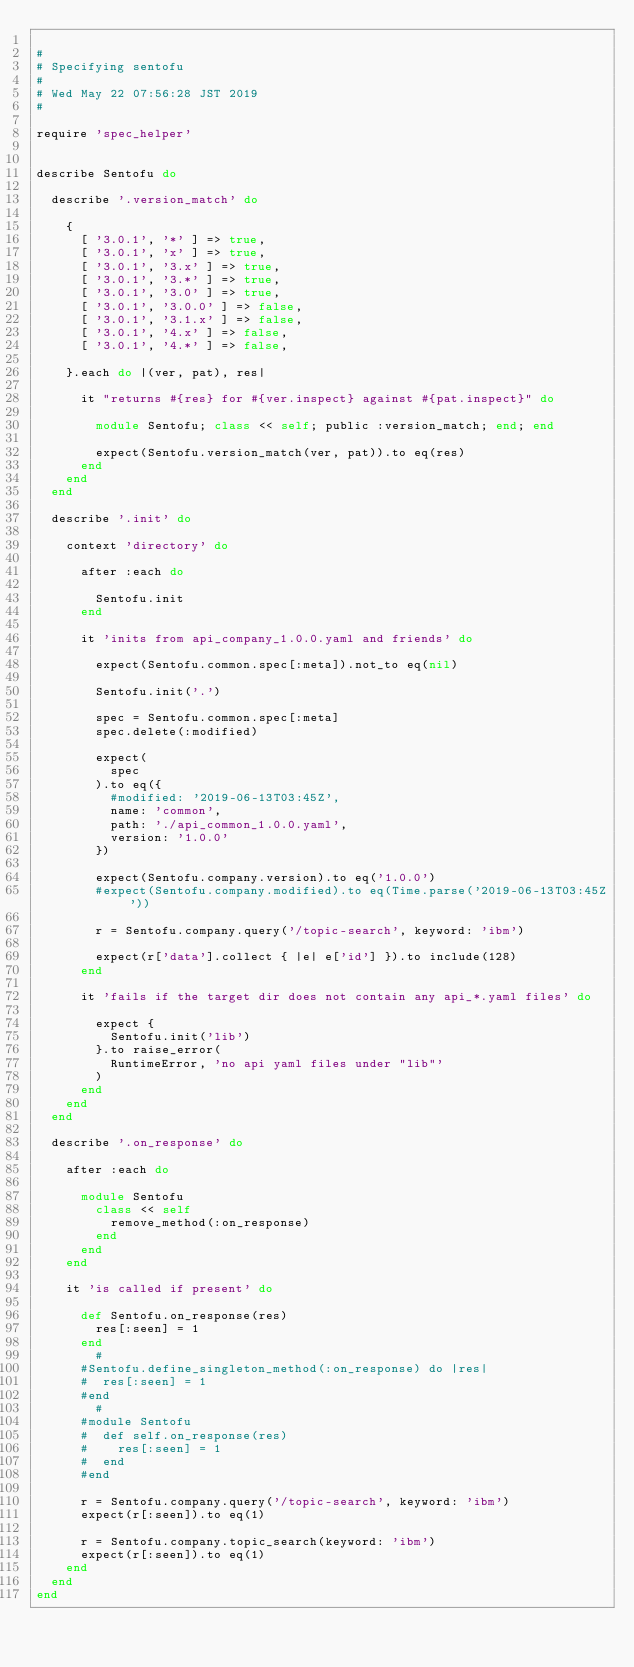Convert code to text. <code><loc_0><loc_0><loc_500><loc_500><_Ruby_>
#
# Specifying sentofu
#
# Wed May 22 07:56:28 JST 2019
#

require 'spec_helper'


describe Sentofu do

  describe '.version_match' do

    {
      [ '3.0.1', '*' ] => true,
      [ '3.0.1', 'x' ] => true,
      [ '3.0.1', '3.x' ] => true,
      [ '3.0.1', '3.*' ] => true,
      [ '3.0.1', '3.0' ] => true,
      [ '3.0.1', '3.0.0' ] => false,
      [ '3.0.1', '3.1.x' ] => false,
      [ '3.0.1', '4.x' ] => false,
      [ '3.0.1', '4.*' ] => false,

    }.each do |(ver, pat), res|

      it "returns #{res} for #{ver.inspect} against #{pat.inspect}" do

        module Sentofu; class << self; public :version_match; end; end

        expect(Sentofu.version_match(ver, pat)).to eq(res)
      end
    end
  end

  describe '.init' do

    context 'directory' do

      after :each do

        Sentofu.init
      end

      it 'inits from api_company_1.0.0.yaml and friends' do

        expect(Sentofu.common.spec[:meta]).not_to eq(nil)

        Sentofu.init('.')

        spec = Sentofu.common.spec[:meta]
        spec.delete(:modified)

        expect(
          spec
        ).to eq({
          #modified: '2019-06-13T03:45Z',
          name: 'common',
          path: './api_common_1.0.0.yaml',
          version: '1.0.0'
        })

        expect(Sentofu.company.version).to eq('1.0.0')
        #expect(Sentofu.company.modified).to eq(Time.parse('2019-06-13T03:45Z'))

        r = Sentofu.company.query('/topic-search', keyword: 'ibm')

        expect(r['data'].collect { |e| e['id'] }).to include(128)
      end

      it 'fails if the target dir does not contain any api_*.yaml files' do

        expect {
          Sentofu.init('lib')
        }.to raise_error(
          RuntimeError, 'no api yaml files under "lib"'
        )
      end
    end
  end

  describe '.on_response' do

    after :each do

      module Sentofu
        class << self
          remove_method(:on_response)
        end
      end
    end

    it 'is called if present' do

      def Sentofu.on_response(res)
        res[:seen] = 1
      end
        #
      #Sentofu.define_singleton_method(:on_response) do |res|
      #  res[:seen] = 1
      #end
        #
      #module Sentofu
      #  def self.on_response(res)
      #    res[:seen] = 1
      #  end
      #end

      r = Sentofu.company.query('/topic-search', keyword: 'ibm')
      expect(r[:seen]).to eq(1)

      r = Sentofu.company.topic_search(keyword: 'ibm')
      expect(r[:seen]).to eq(1)
    end
  end
end

</code> 